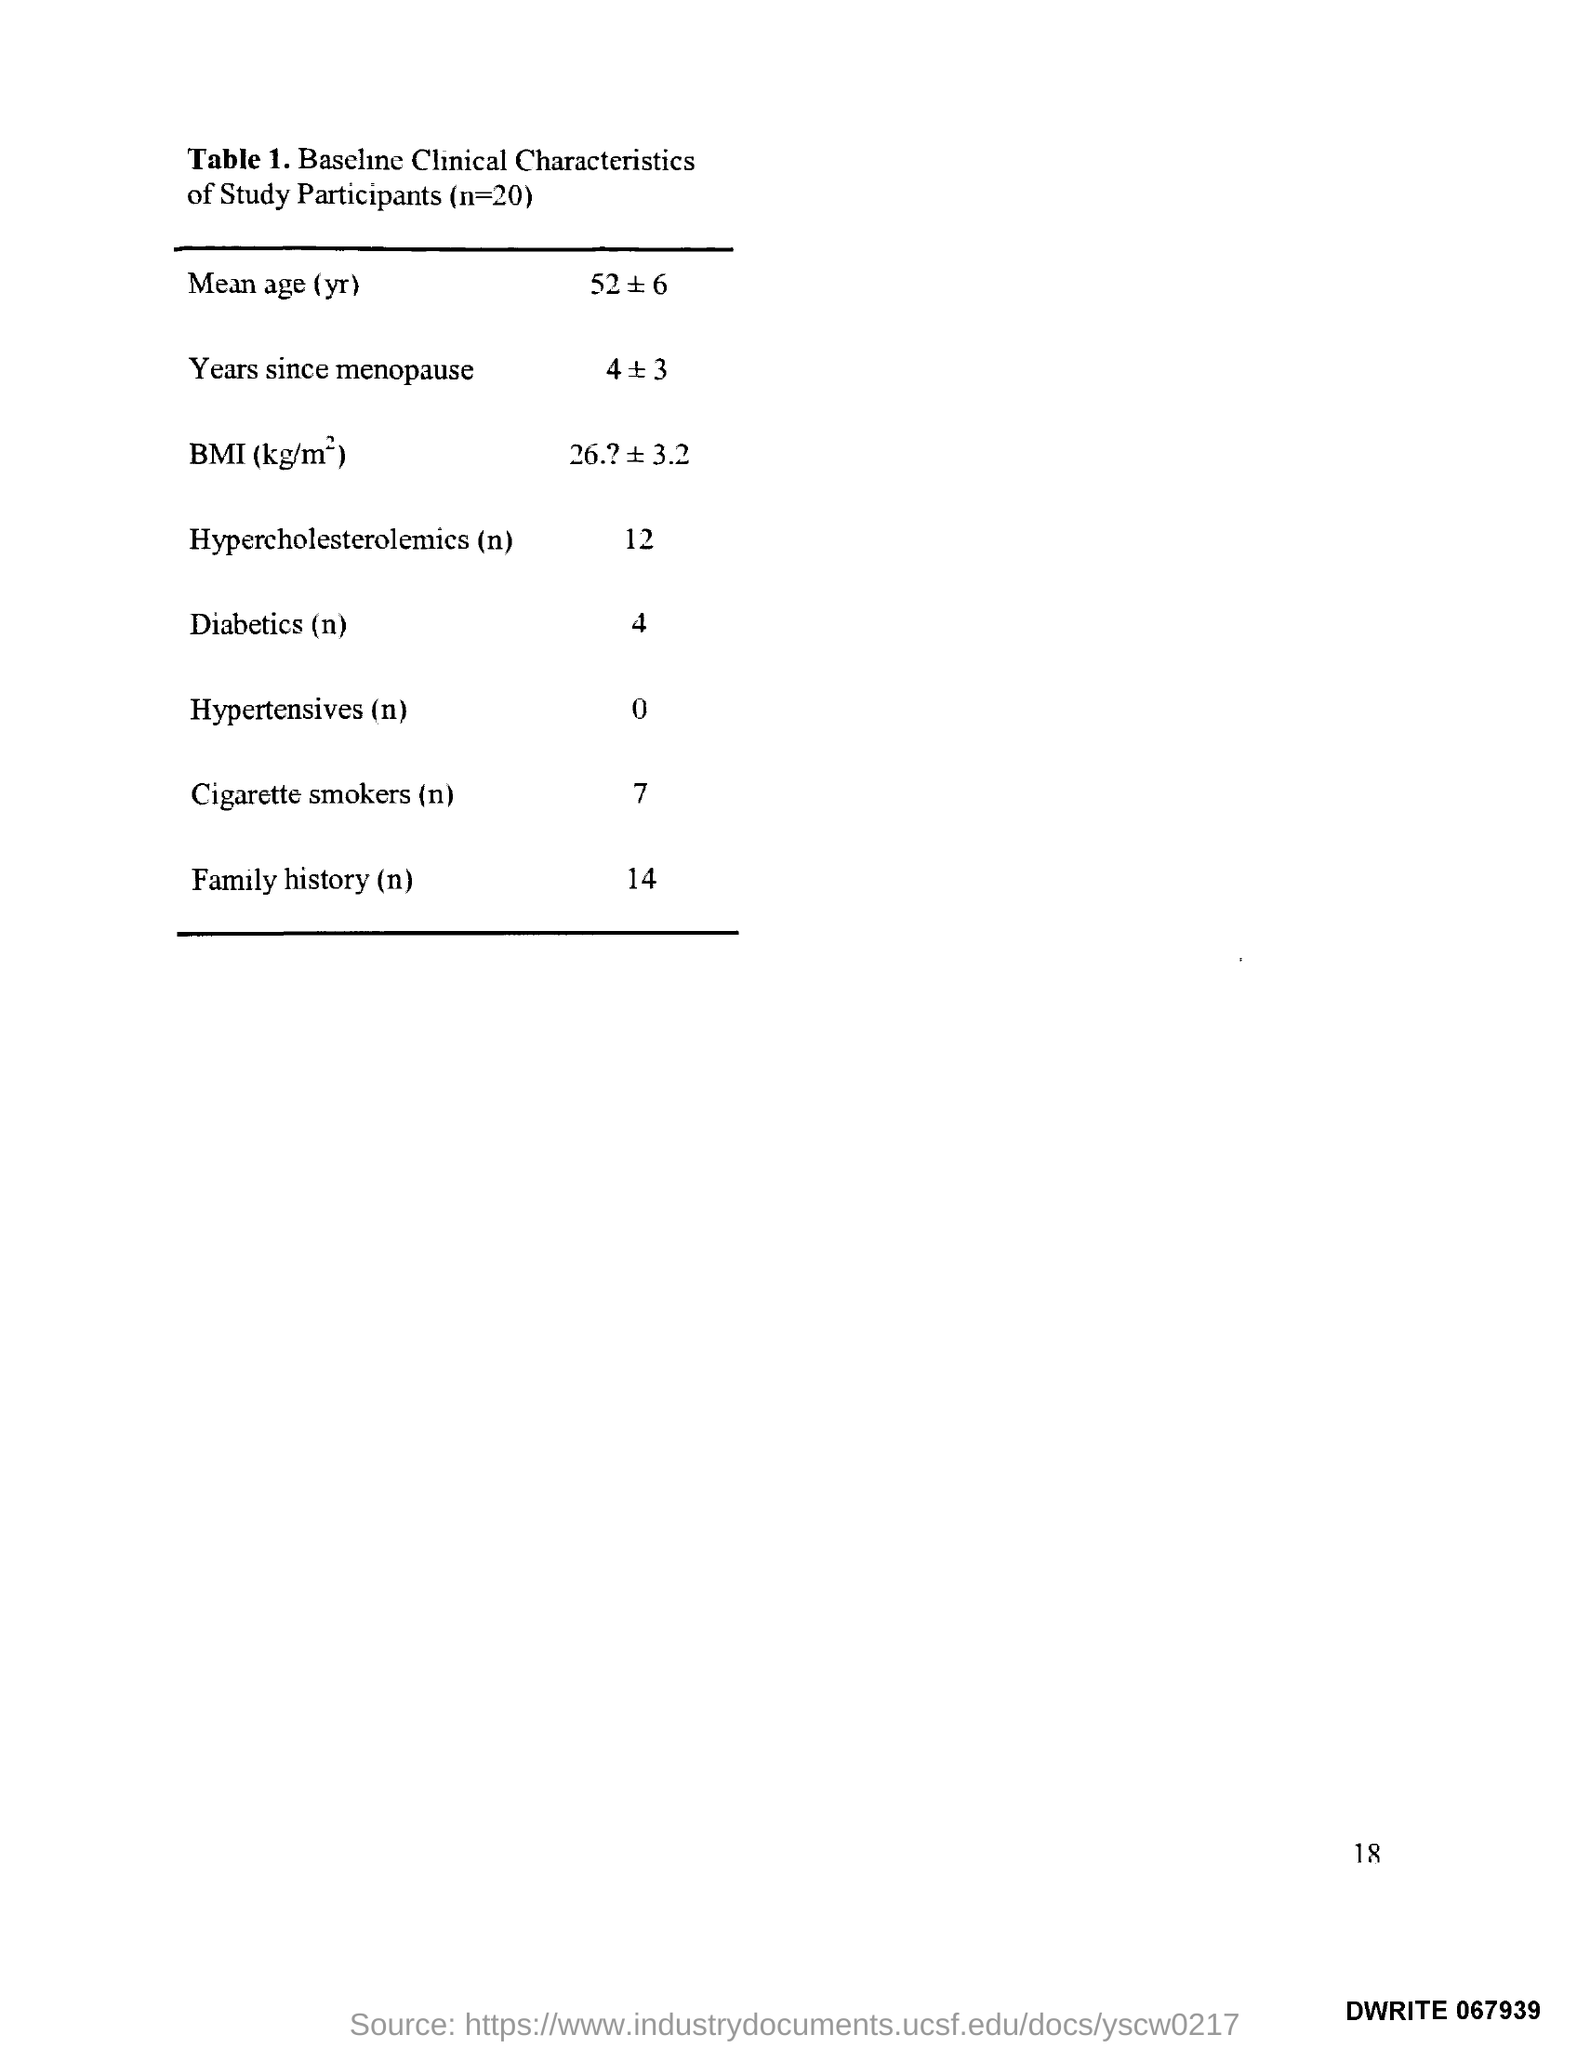Mention a couple of crucial points in this snapshot. The total number of participants is 20. The Page Number is 18. 